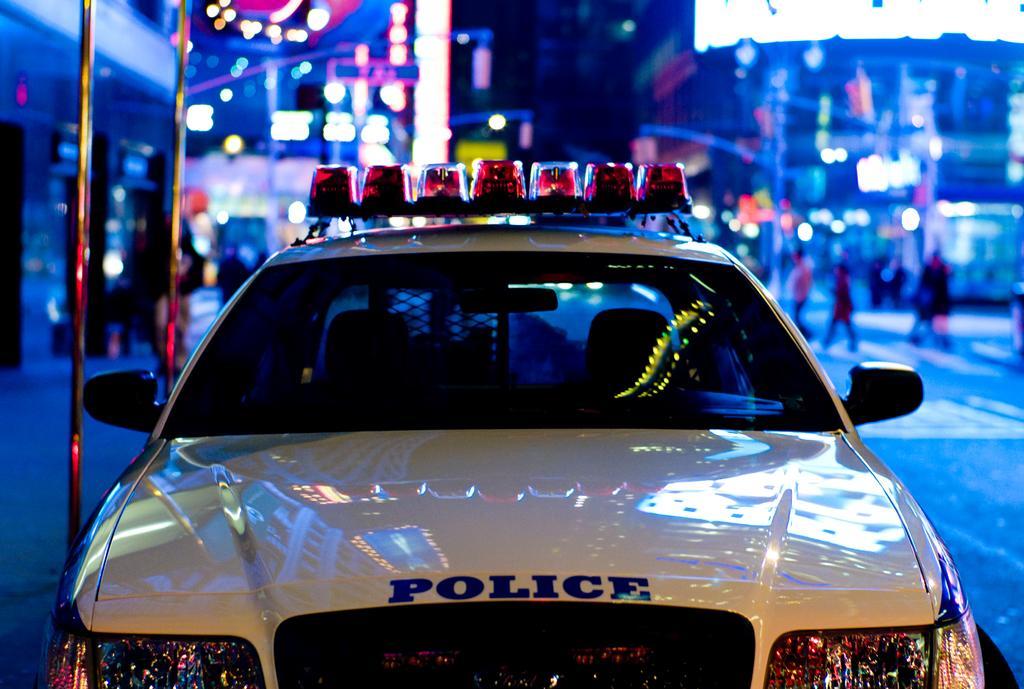Describe this image in one or two sentences. In this image we can see a police car at the center of the image, behind it there are rods, buildings, lights, street lights, posters and a group of people. 